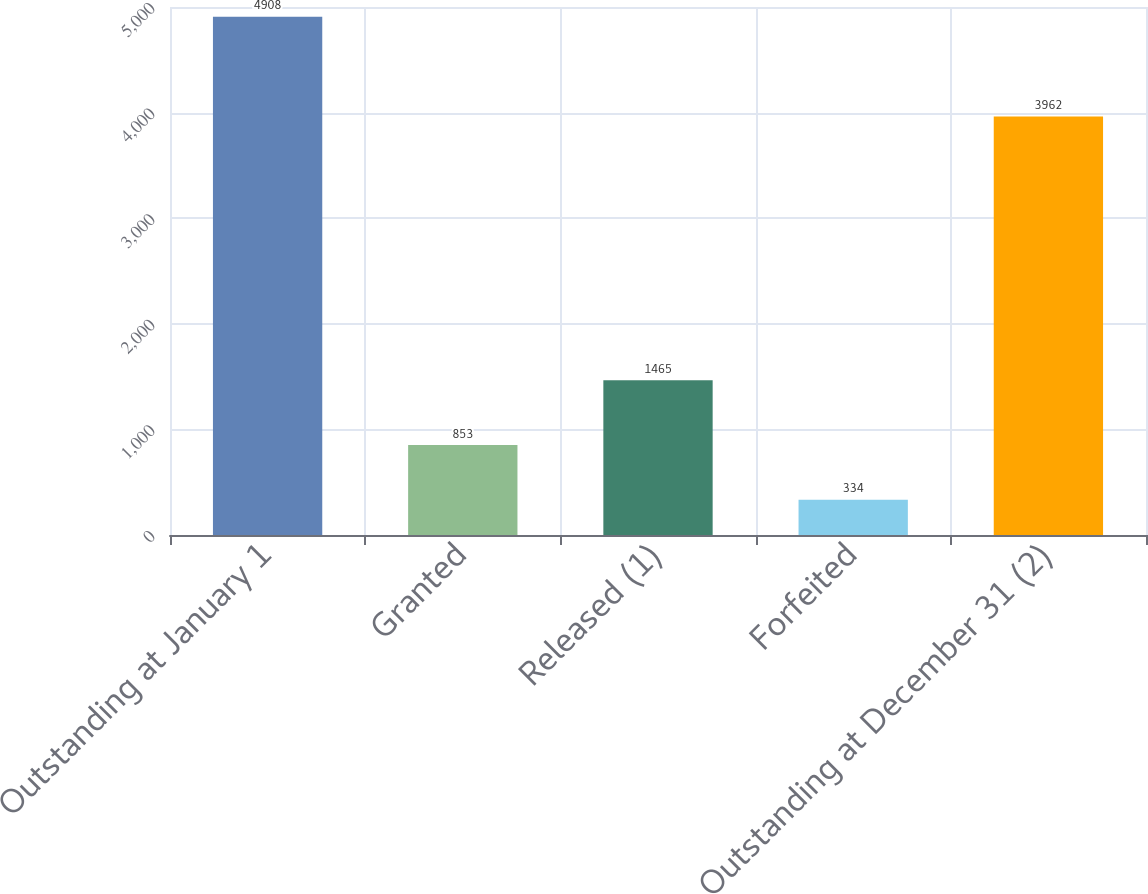Convert chart. <chart><loc_0><loc_0><loc_500><loc_500><bar_chart><fcel>Outstanding at January 1<fcel>Granted<fcel>Released (1)<fcel>Forfeited<fcel>Outstanding at December 31 (2)<nl><fcel>4908<fcel>853<fcel>1465<fcel>334<fcel>3962<nl></chart> 